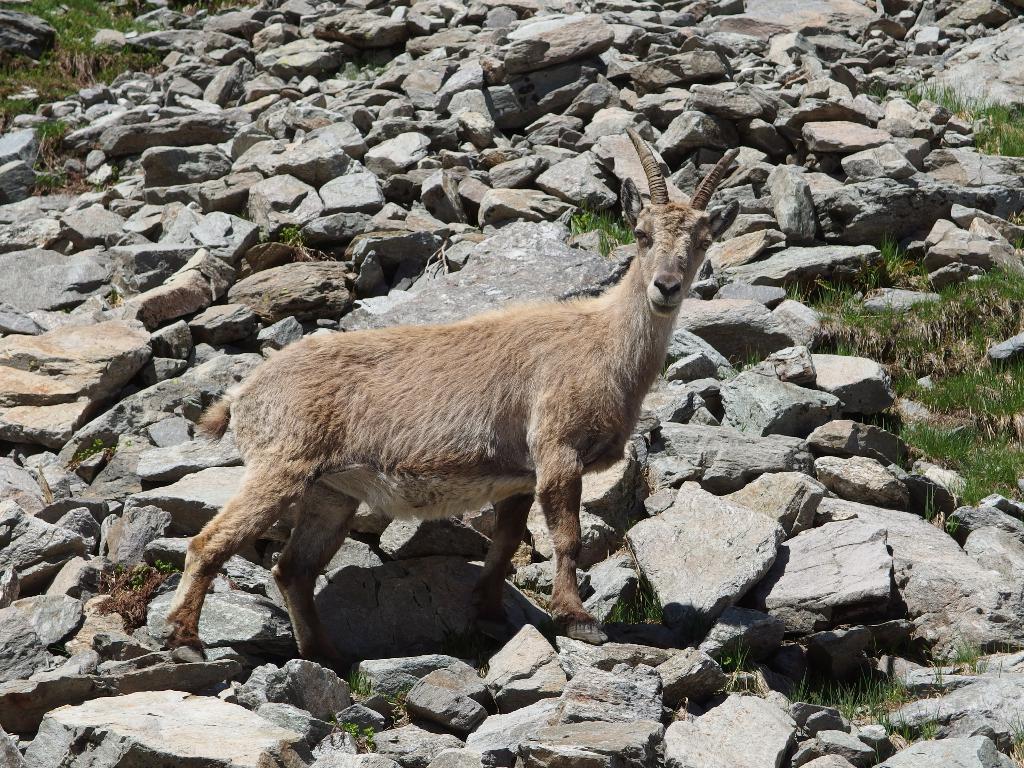Describe this image in one or two sentences. In the center of the image we can see goat standing on the stones. In the background we can see grass and stones. 